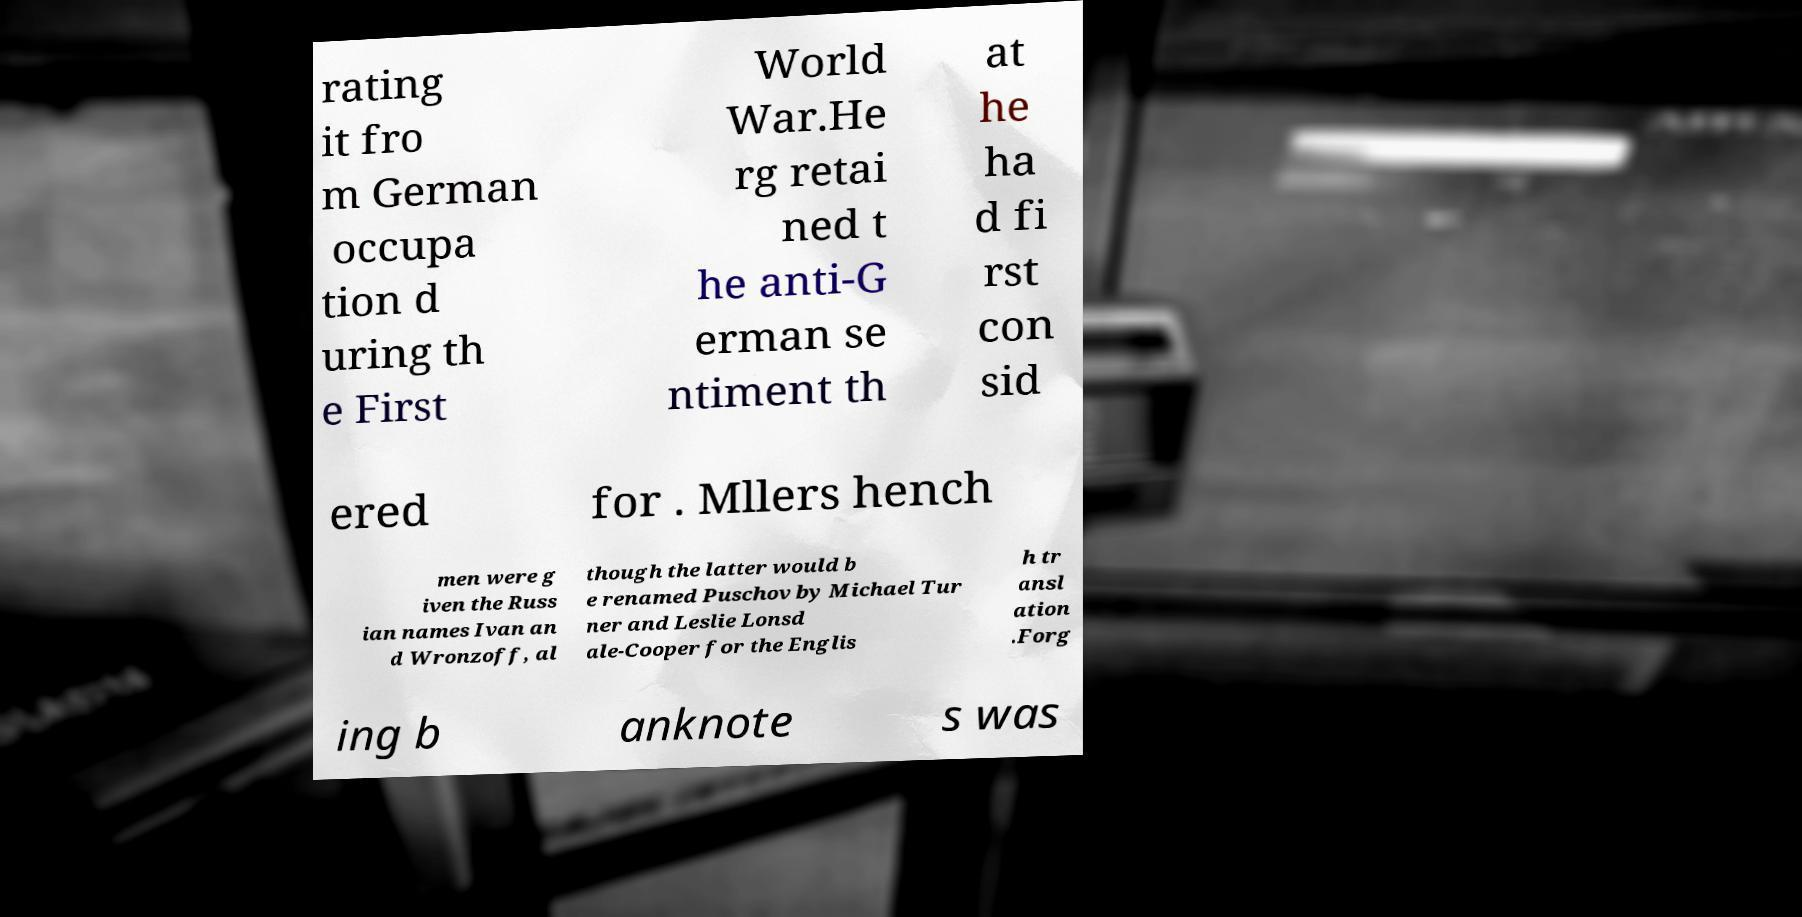What messages or text are displayed in this image? I need them in a readable, typed format. rating it fro m German occupa tion d uring th e First World War.He rg retai ned t he anti-G erman se ntiment th at he ha d fi rst con sid ered for . Mllers hench men were g iven the Russ ian names Ivan an d Wronzoff, al though the latter would b e renamed Puschov by Michael Tur ner and Leslie Lonsd ale-Cooper for the Englis h tr ansl ation .Forg ing b anknote s was 